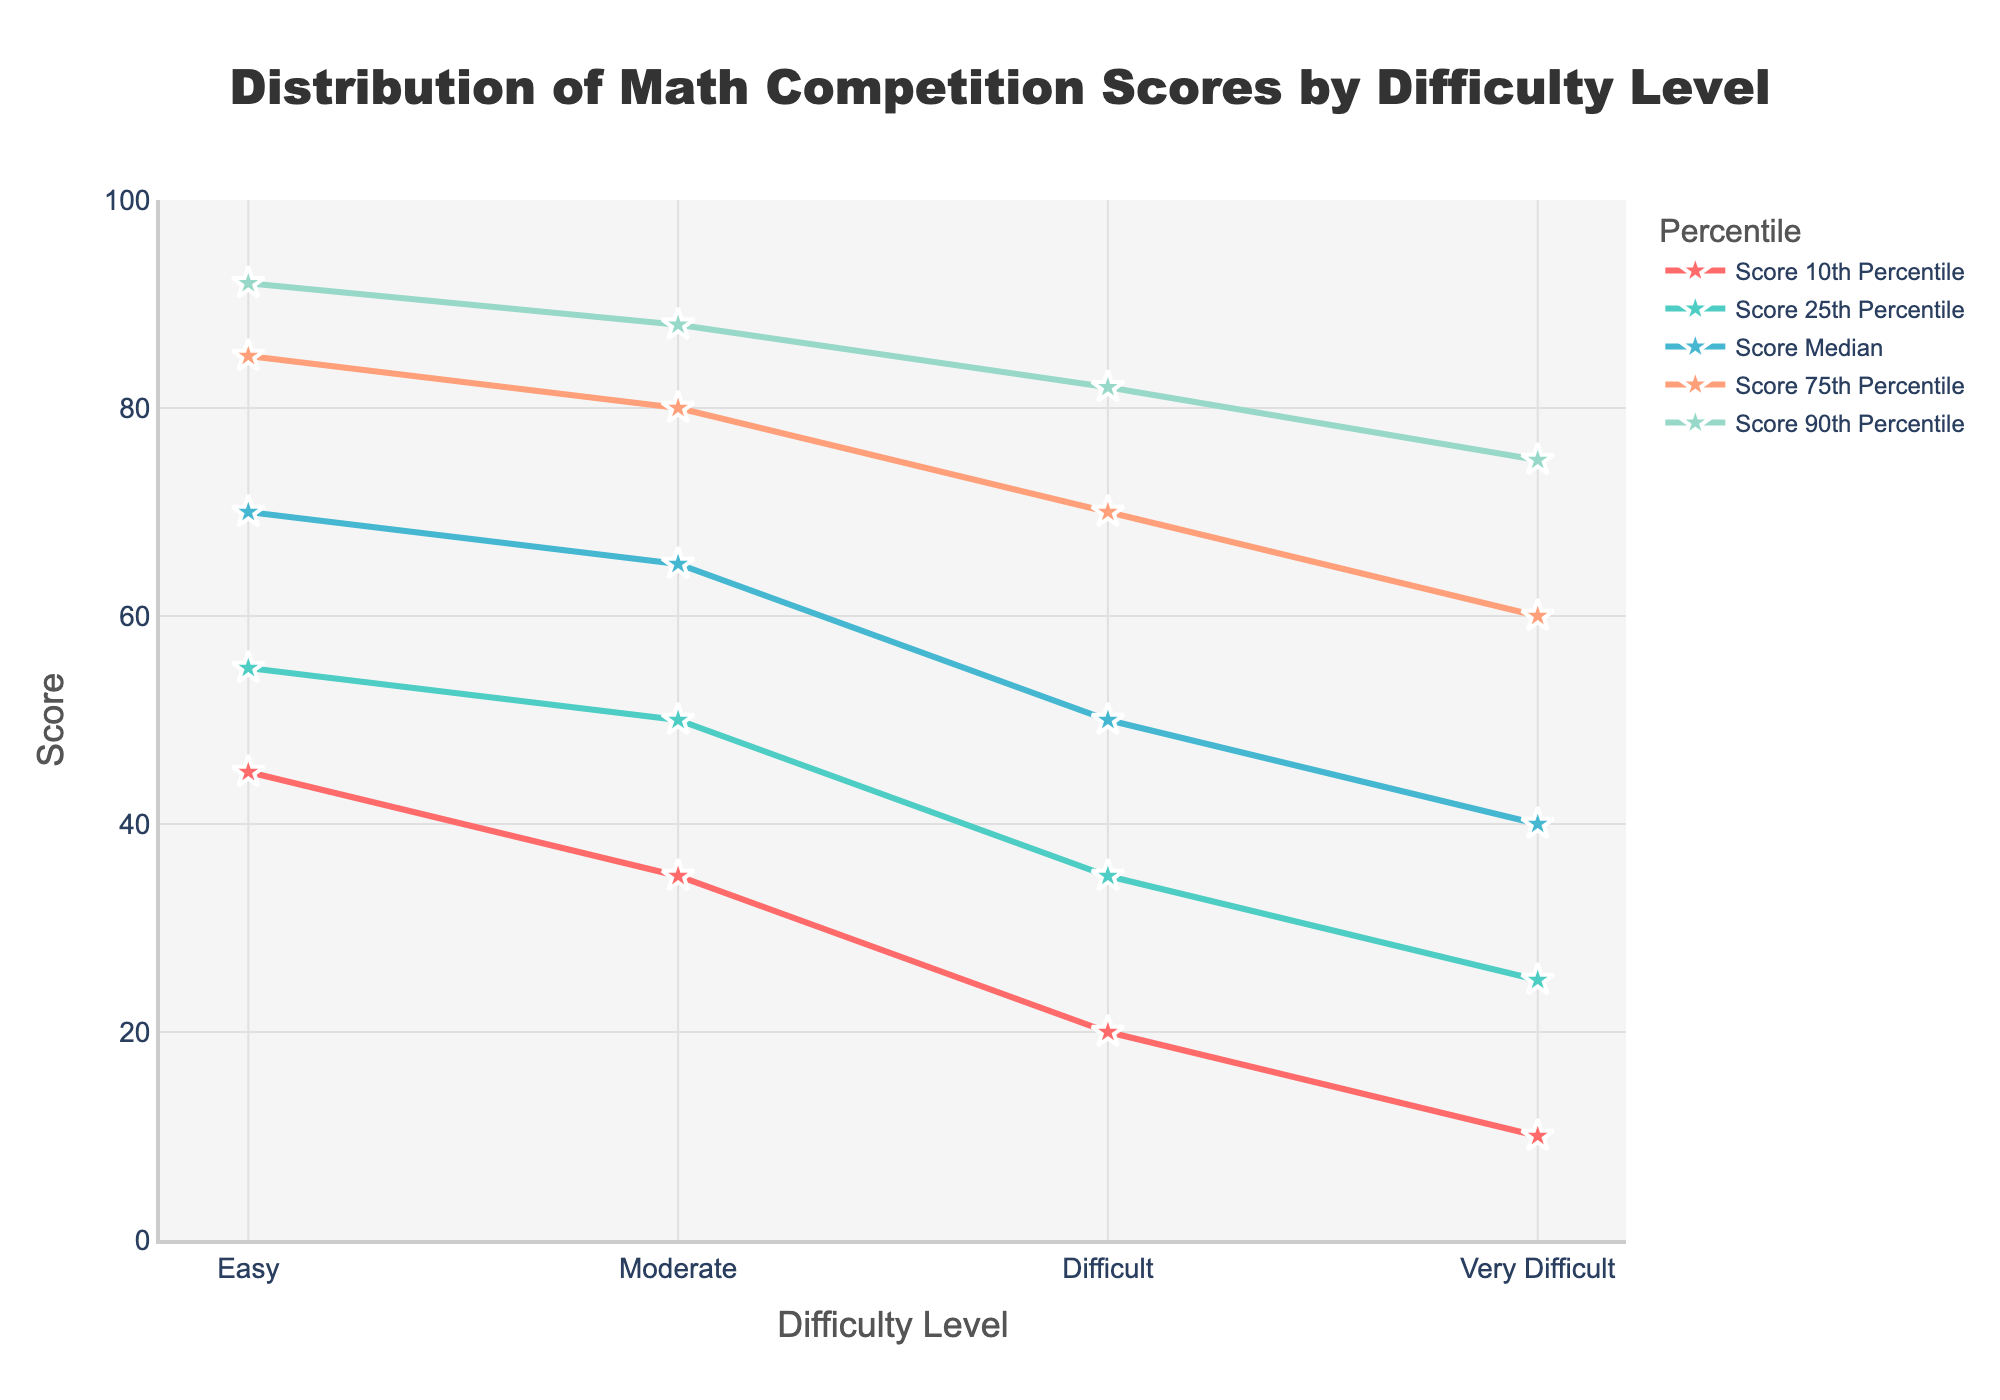What is the title of the plot? The title of the plot is clearly stated at the top of the figure, which describes the content of the plot.
Answer: Distribution of Math Competition Scores by Difficulty Level What are the difficulty levels shown on the x-axis? The x-axis labels represent the different difficulty levels for the math competition.
Answer: Easy, Moderate, Difficult, Very Difficult Which percentile has the highest score for the 'Moderate' difficulty level? For the 'Moderate' difficulty level, we look at the y-axis values of all percentiles and find the highest one. The 90th percentile shows the highest score.
Answer: 90th Percentile By how many points does the median score decrease from 'Easy' to 'Very Difficult'? To find the decrease, subtract the median score of 'Very Difficult' (40) from the median score of 'Easy' (70).
Answer: 30 Which percentile shows the largest difference in scores between 'Easy' and 'Difficult' levels? For each percentile, subtract the score at 'Difficult' from the score at 'Easy', and identify the largest difference.
Answer: 75th Percentile What is the score range for the 25th percentile across all difficulty levels? To find the range, identify the maximum and minimum scores at the 25th percentile and subtract the minimum from the maximum.
Answer: 30 Is the score at the 10th percentile of 'Difficult' higher or lower than the 25th percentile of 'Very Difficult'? Compare the score at the 10th percentile of 'Difficult' (20) with the score at the 25th percentile of 'Very Difficult' (25).
Answer: Lower Which percentile line shows the steepest increase as difficulty level increases from 'Easy' to 'Very Difficult'? Compare the steepness of increase for each percentile line across all difficulty levels and identify the one with the highest slope or rate of increase.
Answer: 10th Percentile What is the difference between the 75th and 25th percentile scores for 'Easy' difficulty? Subtract the score at the 25th percentile from the score at the 75th percentile for 'Easy' difficulty.
Answer: 30 For the 'Very Difficult' level, which percentile has the largest gap to the next higher percentile? Calculate the differences between consecutive percentiles and find the largest difference for 'Very Difficult'.
Answer: 10th to 25th Percentile 